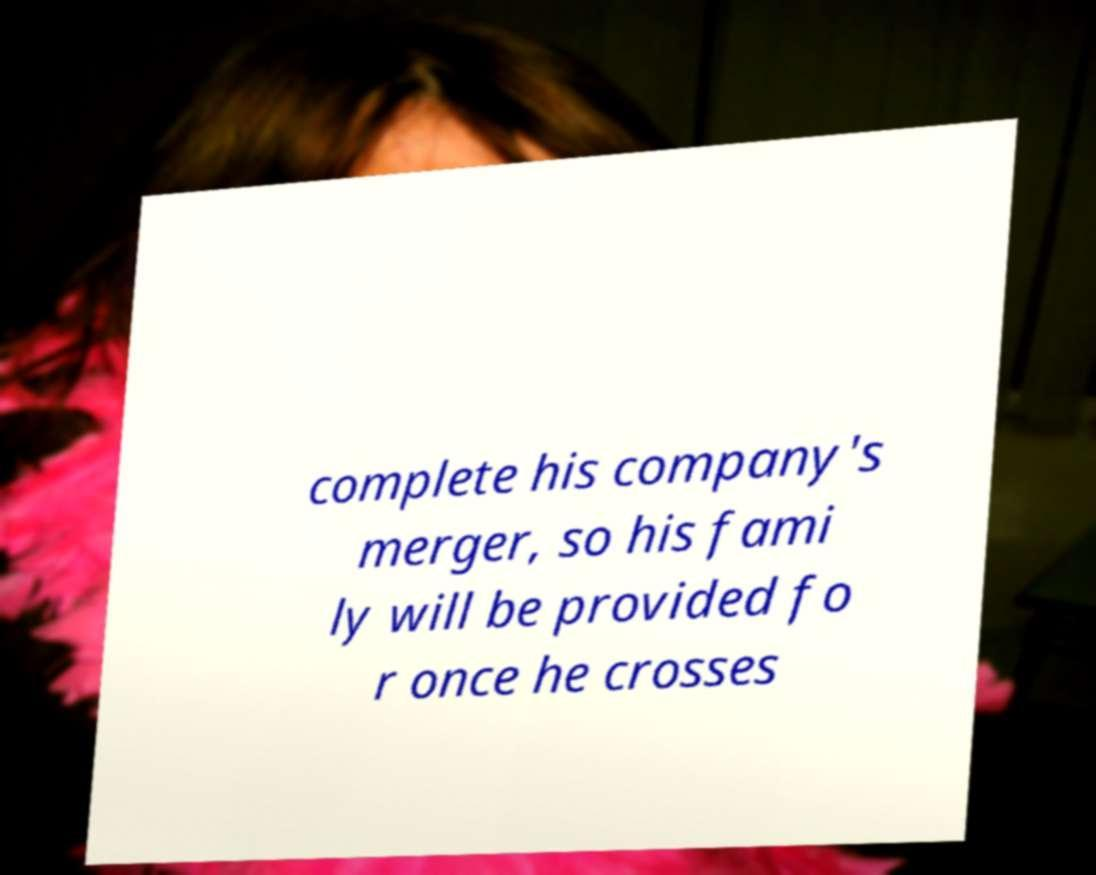Please read and relay the text visible in this image. What does it say? complete his company's merger, so his fami ly will be provided fo r once he crosses 